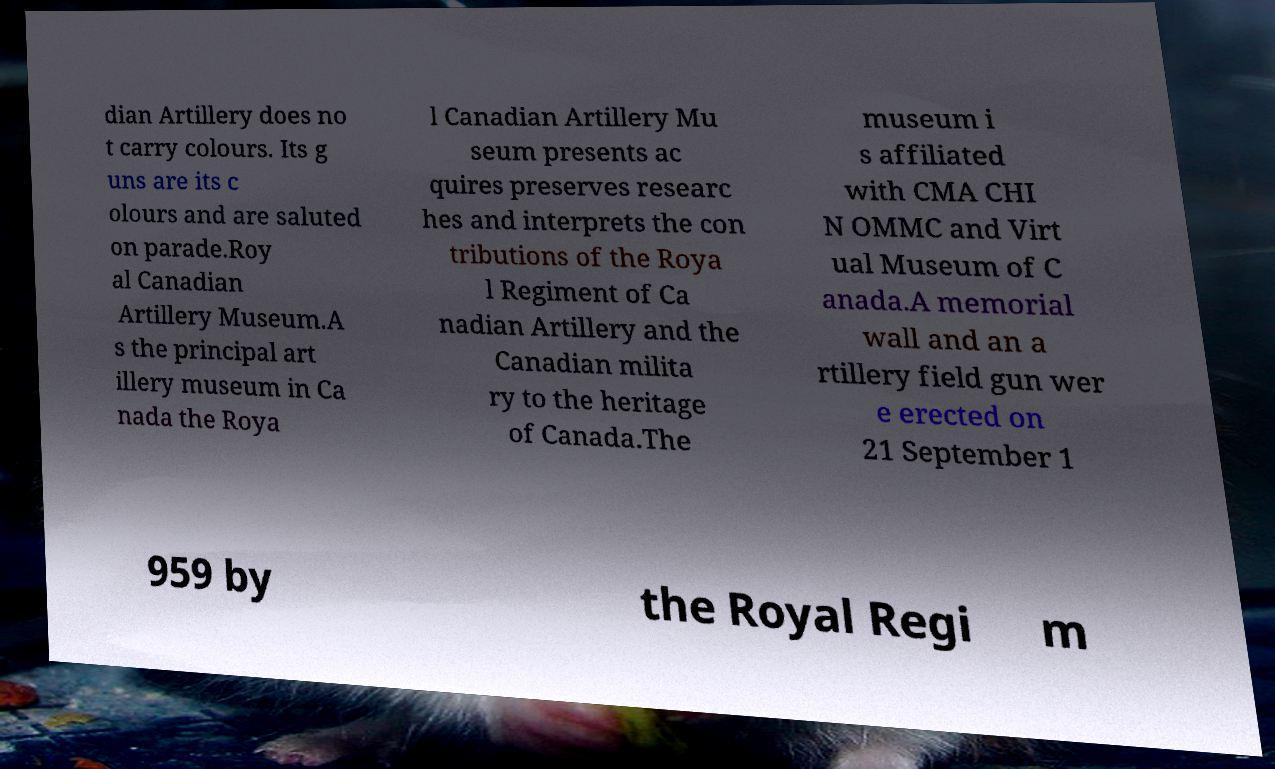There's text embedded in this image that I need extracted. Can you transcribe it verbatim? dian Artillery does no t carry colours. Its g uns are its c olours and are saluted on parade.Roy al Canadian Artillery Museum.A s the principal art illery museum in Ca nada the Roya l Canadian Artillery Mu seum presents ac quires preserves researc hes and interprets the con tributions of the Roya l Regiment of Ca nadian Artillery and the Canadian milita ry to the heritage of Canada.The museum i s affiliated with CMA CHI N OMMC and Virt ual Museum of C anada.A memorial wall and an a rtillery field gun wer e erected on 21 September 1 959 by the Royal Regi m 